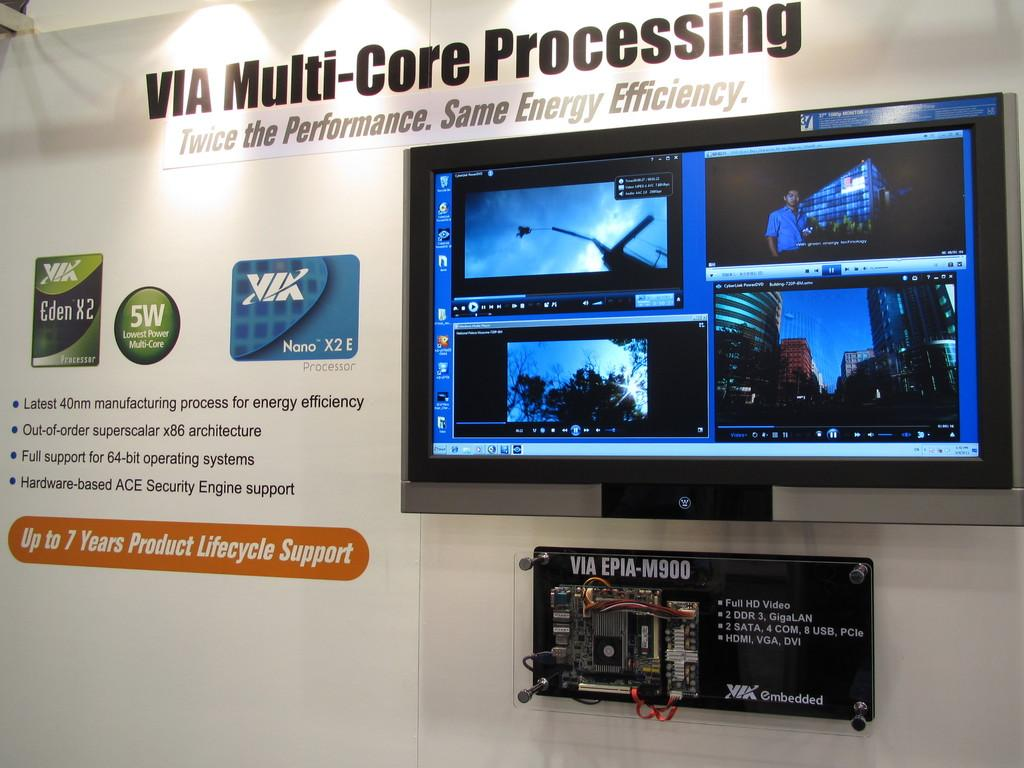<image>
Share a concise interpretation of the image provided. A large display board presents information about VIA Multi-Core Processing technology. 